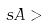Convert formula to latex. <formula><loc_0><loc_0><loc_500><loc_500>s A ></formula> 